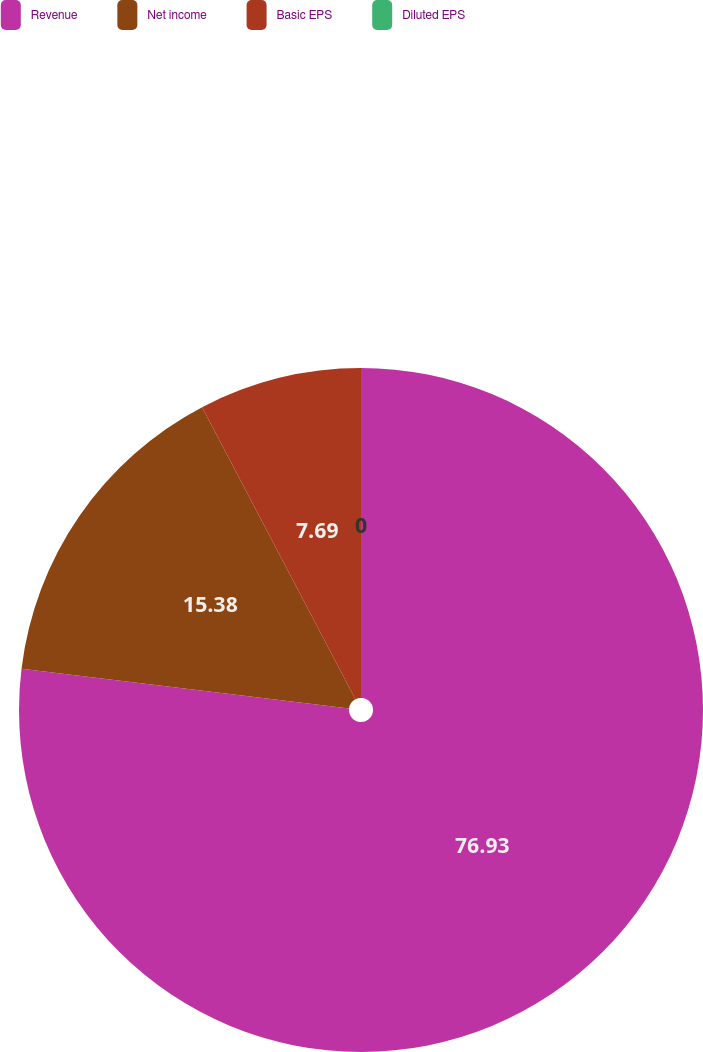Convert chart. <chart><loc_0><loc_0><loc_500><loc_500><pie_chart><fcel>Revenue<fcel>Net income<fcel>Basic EPS<fcel>Diluted EPS<nl><fcel>76.92%<fcel>15.38%<fcel>7.69%<fcel>0.0%<nl></chart> 